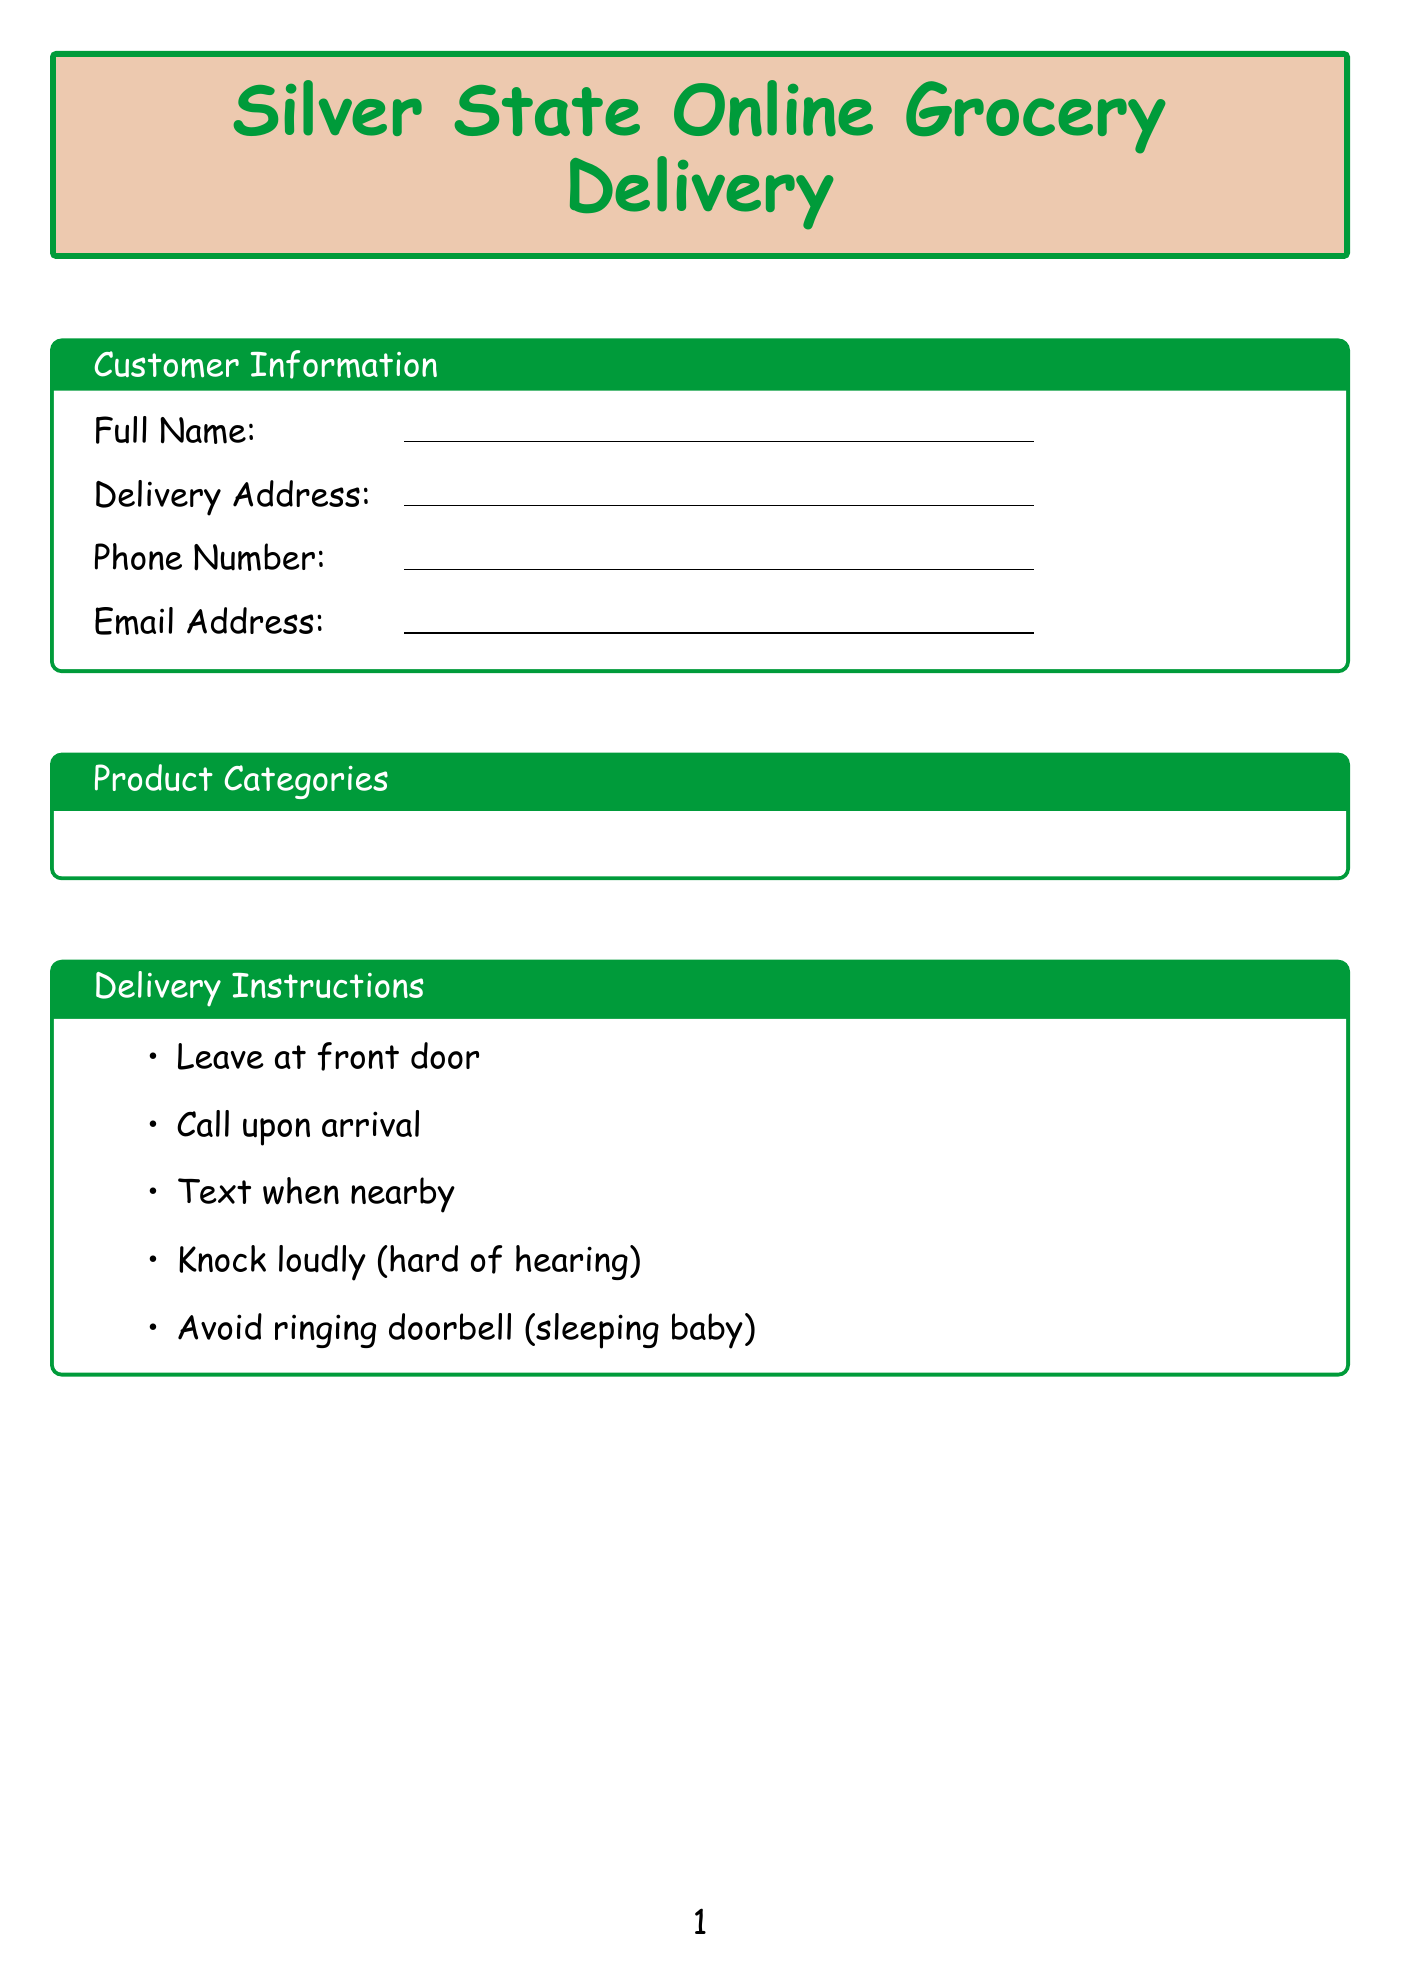What is the form title? The form title is prominently displayed at the top of the document, which identifies the purpose of the form.
Answer: Silver State Online Grocery Delivery What is the delivery address field labeled as? This is a specific information retrieval question that asks for the exact label used in the document for the delivery address input.
Answer: Delivery Address What payment options are available? This question is about identifying the specific payment methods listed in the document.
Answer: Credit Card, PayPal, EBT/SNAP, Cash on Delivery What are the COVID-19 safety measures mentioned? This question requires recalling multiple items listed under COVID-19 safety, which can include various health precautions.
Answer: Contactless delivery available, All shoppers wear masks, Regular sanitization of delivery vehicles, Temperature checks for staff How many local stores are listed? This question involves counting the local stores mentioned in the document, which requires a quick tally.
Answer: 5 What should be done if the baby is sleeping? This question asks for specific delivery instructions based on a scenario described in the document.
Answer: Avoid ringing doorbell What are the special requests for? This is a unique question regarding the purpose of a specific section of the form that allows additional input from the customer.
Answer: Any special requests or notes for your order? Which social media platforms are mentioned? This question covers the specific platforms listed for connecting with the grocery service, requiring the identification of multiple entities.
Answer: Facebook, Twitter, Instagram What are the delivery time slots available? This question requests the specific time frames for delivery listed in the document.
Answer: 9:00 AM - 11:00 AM, 11:00 AM - 1:00 PM, 1:00 PM - 3:00 PM, 3:00 PM - 5:00 PM, 5:00 PM - 7:00 PM 